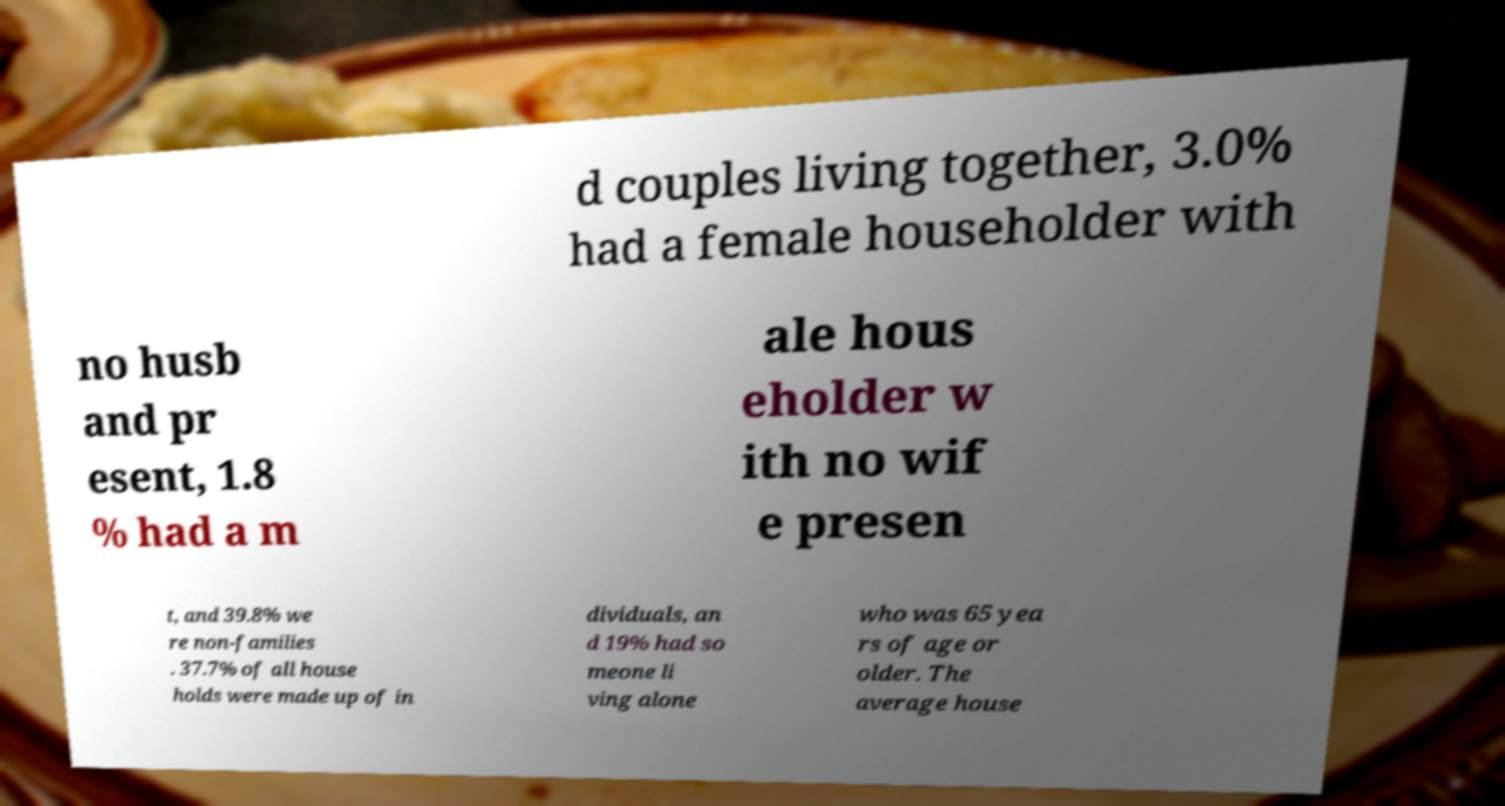For documentation purposes, I need the text within this image transcribed. Could you provide that? d couples living together, 3.0% had a female householder with no husb and pr esent, 1.8 % had a m ale hous eholder w ith no wif e presen t, and 39.8% we re non-families . 37.7% of all house holds were made up of in dividuals, an d 19% had so meone li ving alone who was 65 yea rs of age or older. The average house 